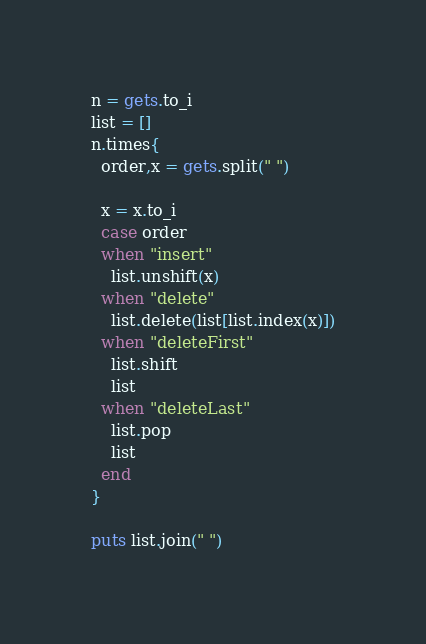Convert code to text. <code><loc_0><loc_0><loc_500><loc_500><_Ruby_>n = gets.to_i
list = []
n.times{
  order,x = gets.split(" ")

  x = x.to_i
  case order
  when "insert"
    list.unshift(x)
  when "delete"
    list.delete(list[list.index(x)])
  when "deleteFirst"
    list.shift
    list
  when "deleteLast"
    list.pop
  	list
  end
}

puts list.join(" ")</code> 